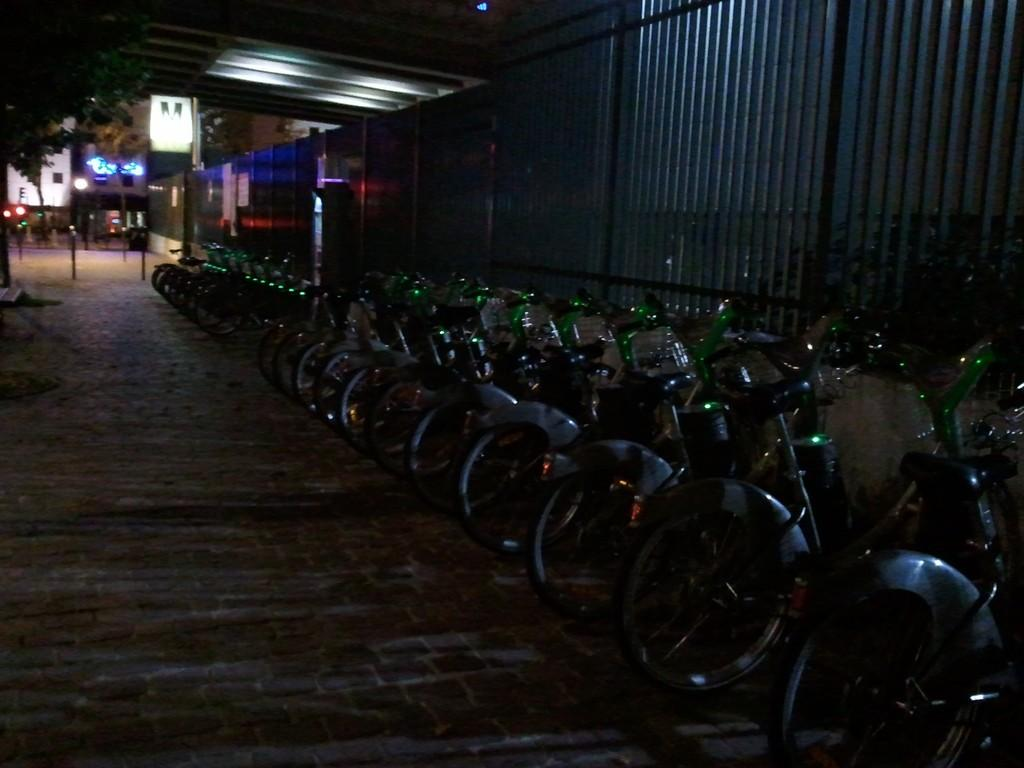What can be seen on the ground in the image? There are bicycles on the ground in the image. What type of natural element is present in the image? There is a tree in the image. What type of structure is present in the image? There is a wall in the image. What are the vertical structures in the image? There are poles in the image. What are the sources of illumination in the image? There are lights in the image. What other objects can be seen in the image? There are some objects in the image. What can be seen in the distance in the image? There are buildings visible in the background of the image. How many boys are sitting on the bicycles in the image? There is no mention of boys in the image; it only shows bicycles on the ground. What type of clouds can be seen in the image? There is no mention of clouds in the image; it only shows a tree, a wall, poles, lights, objects, and buildings. 